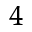<formula> <loc_0><loc_0><loc_500><loc_500>^ { 4 }</formula> 